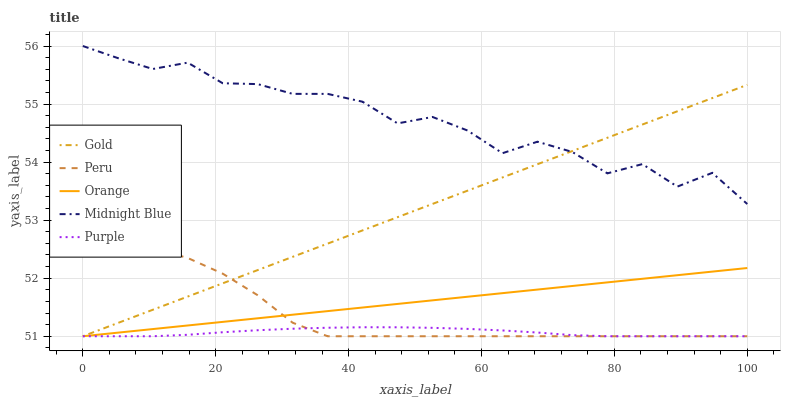Does Purple have the minimum area under the curve?
Answer yes or no. Yes. Does Midnight Blue have the maximum area under the curve?
Answer yes or no. Yes. Does Peru have the minimum area under the curve?
Answer yes or no. No. Does Peru have the maximum area under the curve?
Answer yes or no. No. Is Orange the smoothest?
Answer yes or no. Yes. Is Midnight Blue the roughest?
Answer yes or no. Yes. Is Purple the smoothest?
Answer yes or no. No. Is Purple the roughest?
Answer yes or no. No. Does Midnight Blue have the lowest value?
Answer yes or no. No. Does Peru have the highest value?
Answer yes or no. No. Is Peru less than Midnight Blue?
Answer yes or no. Yes. Is Midnight Blue greater than Purple?
Answer yes or no. Yes. Does Peru intersect Midnight Blue?
Answer yes or no. No. 